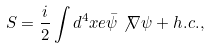<formula> <loc_0><loc_0><loc_500><loc_500>S = \frac { i } { 2 } \int d ^ { 4 } x e \bar { \psi } \not \nabla \psi + h . c . ,</formula> 